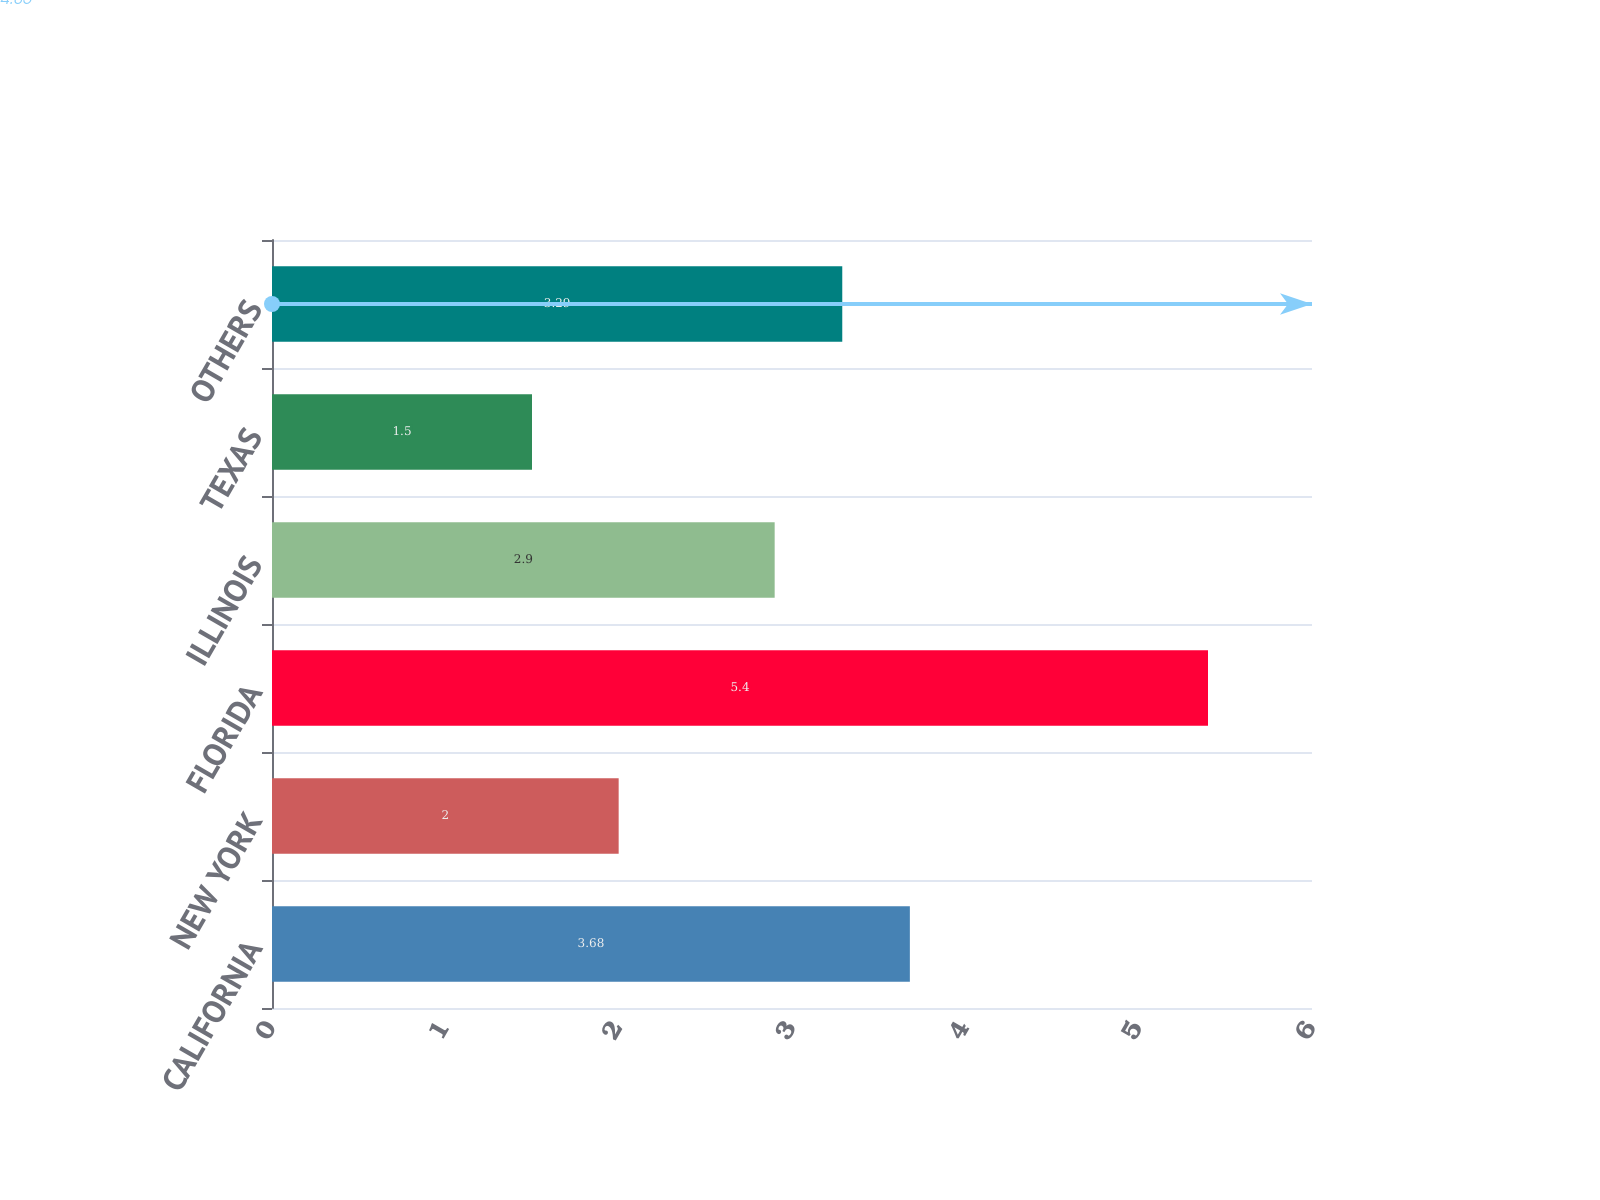Convert chart to OTSL. <chart><loc_0><loc_0><loc_500><loc_500><bar_chart><fcel>CALIFORNIA<fcel>NEW YORK<fcel>FLORIDA<fcel>ILLINOIS<fcel>TEXAS<fcel>OTHERS<nl><fcel>3.68<fcel>2<fcel>5.4<fcel>2.9<fcel>1.5<fcel>3.29<nl></chart> 